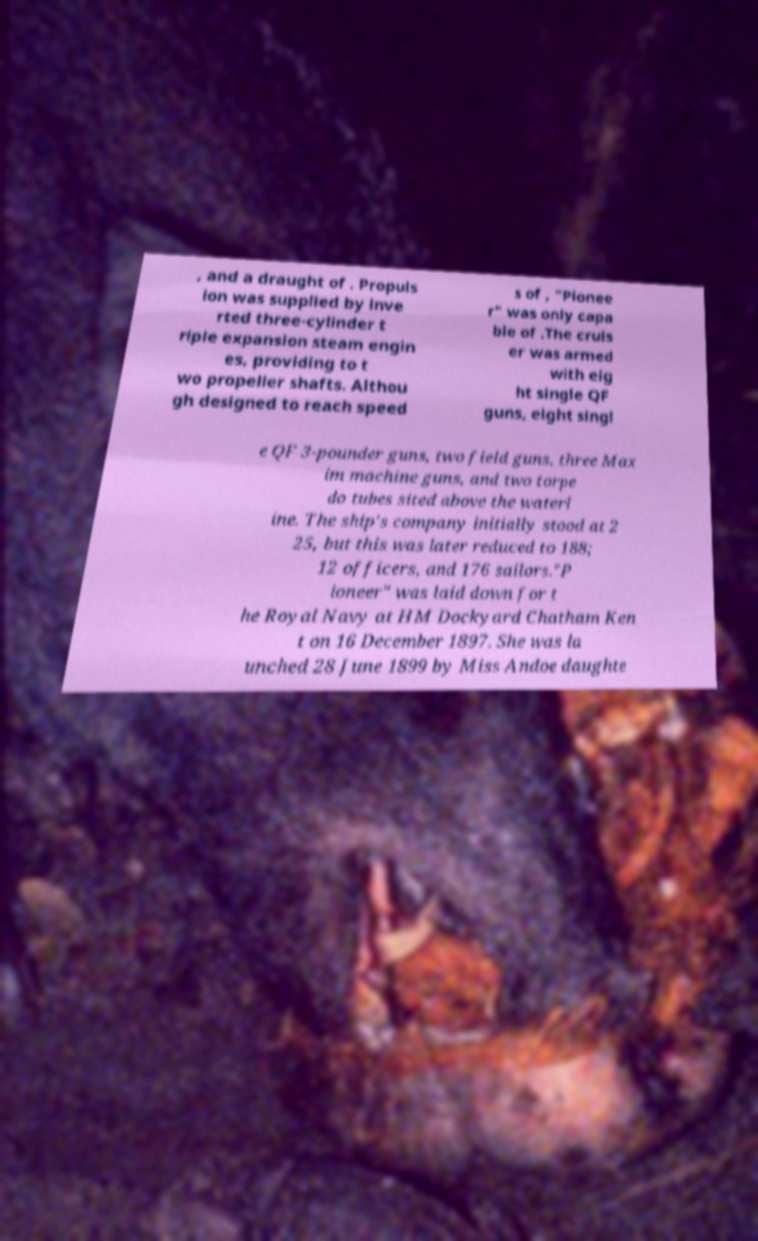I need the written content from this picture converted into text. Can you do that? , and a draught of . Propuls ion was supplied by inve rted three-cylinder t riple expansion steam engin es, providing to t wo propeller shafts. Althou gh designed to reach speed s of , "Pionee r" was only capa ble of .The cruis er was armed with eig ht single QF guns, eight singl e QF 3-pounder guns, two field guns, three Max im machine guns, and two torpe do tubes sited above the waterl ine. The ship's company initially stood at 2 25, but this was later reduced to 188; 12 officers, and 176 sailors."P ioneer" was laid down for t he Royal Navy at HM Dockyard Chatham Ken t on 16 December 1897. She was la unched 28 June 1899 by Miss Andoe daughte 